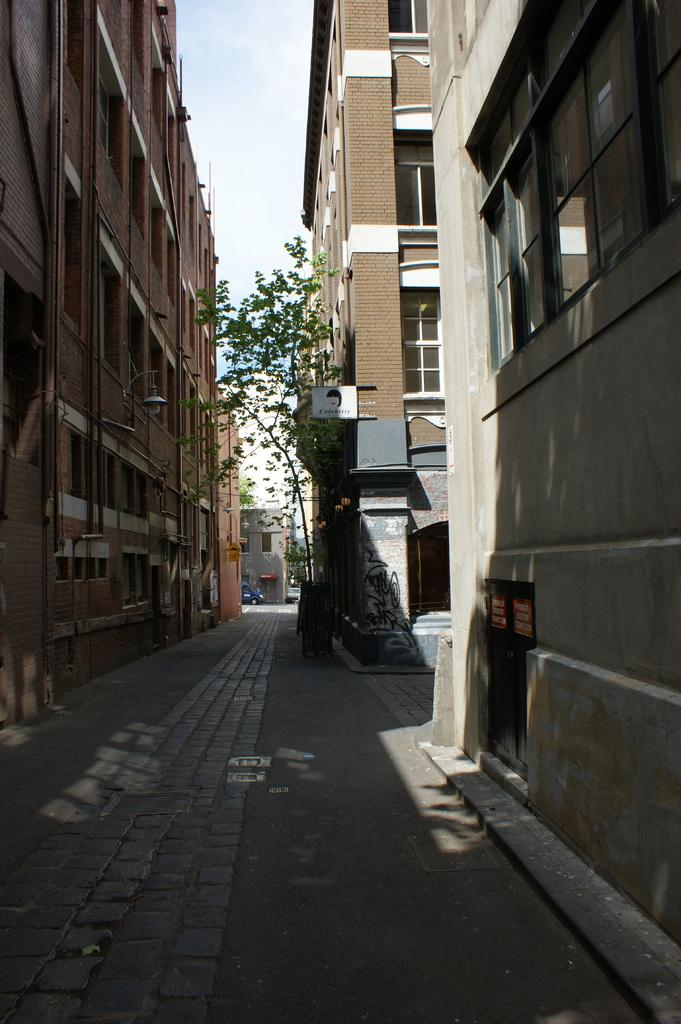What type of structures can be seen in the image? There are buildings in the image. What feature can be observed on the buildings? There are windows visible in the image. What type of vegetation is present in the image? There are trees in the image. What mode of transportation can be seen on the road in the image? There are vehicles on the road in the image. What is the color of the sky in the image? The sky is blue and white in color. Can you tell me how many letters the pig is holding in the image? There is no pig present in the image, and therefore no letters can be observed. What is the pig's stomach doing in the image? There is no pig or stomach present in the image. 